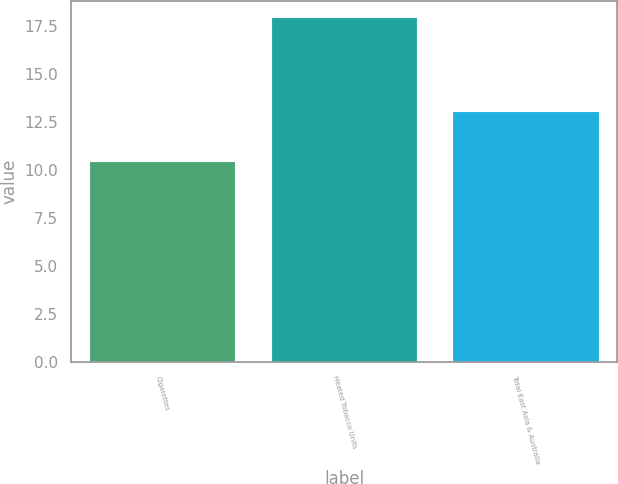Convert chart. <chart><loc_0><loc_0><loc_500><loc_500><bar_chart><fcel>Cigarettes<fcel>Heated Tobacco Units<fcel>Total East Asia & Australia<nl><fcel>10.4<fcel>17.9<fcel>13<nl></chart> 